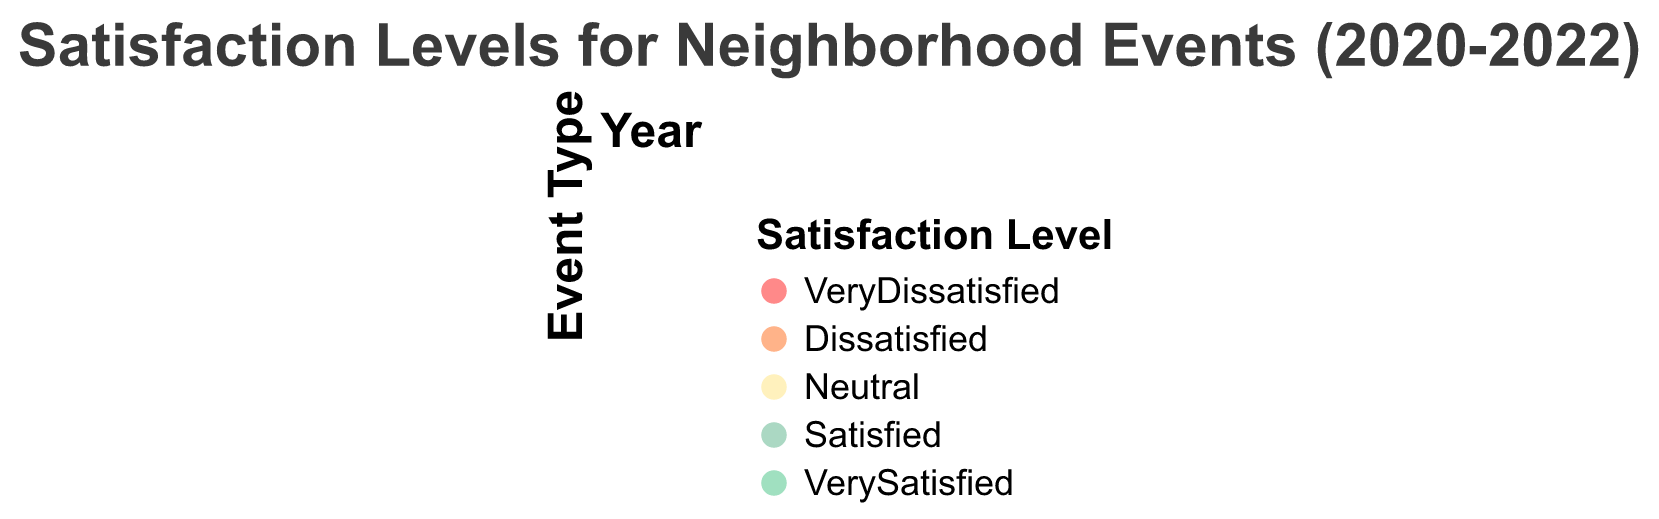What's the title of the figure? The title of the figure is displayed prominently, usually at the top, and summarizes the content of the figure.
Answer: Satisfaction Levels for Neighborhood Events (2020-2022) How many Event Types are shown in each year? Each year column shows one subplot for each of the three event types: Spring Festival, Community Picnic, and Halloween Party.
Answer: Three Which Event Type had the highest "VerySatisfied" percentage in 2022? In 2022, the Halloween Party has the largest segment in the "VerySatisfied" category, which indicates the highest "VerySatisfied" percentage.
Answer: Halloween Party Compare the "Dissatisfied" percentages for the Spring Festival between 2020 and 2022. Which year had a lower percentage? The "Dissatisfied" level for the Spring Festival is represented by a segment in the arc. In 2020, it was 10, and in 2022, it was 5. Hence, 2022 had a lower percentage.
Answer: 2022 What is the sum of the "Satisfied" counts for Community Picnic in 2020 and 2021? The "Satisfied" count for Community Picnic in 2020 is 60 and for 2021 is 65. Summing these values gives 60 + 65 = 125.
Answer: 125 Which year shows the largest improvement in "VerySatisfied" for the Halloween Party when compared to the previous year? By comparing the values for "VerySatisfied" across the years for the Halloween Party: 40 in 2020, 50 in 2021, and 70 in 2022; the largest improvement is from 2021 to 2022 (20 points).
Answer: 2022 In which year was the "Neutral" sentiment the highest for the Spring Festival, and what was the value? The "Neutral" bar for the Spring Festival is the tallest in 2020, with a value of 30.
Answer: 2020, 30 Rank the events in 2022 from highest to lowest based on the "VerySatisfied" percentages. In 2022, the "VerySatisfied" segments are largest for Halloween Party (70), followed by Community Picnic (65), and then Spring Festival (60). This gives us the ranking.
Answer: Halloween Party, Community Picnic, Spring Festival Which Event Type had the most consistent satisfaction levels (least changes in values) from 2020 to 2022? For the consistent satisfaction levels, we need to look at the event types with minimal changes across the years. Community Picnic has consistent values in "Satisfied" and "VerySatisfied" categories with slight changes.
Answer: Community Picnic 